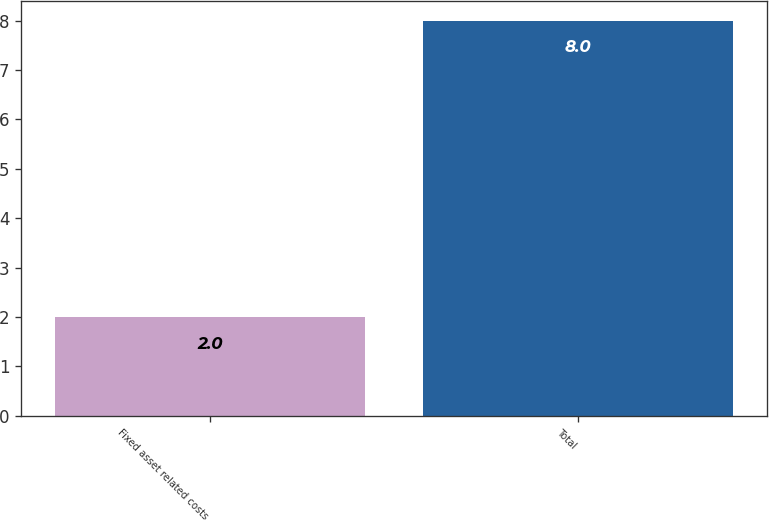Convert chart to OTSL. <chart><loc_0><loc_0><loc_500><loc_500><bar_chart><fcel>Fixed asset related costs<fcel>Total<nl><fcel>2<fcel>8<nl></chart> 